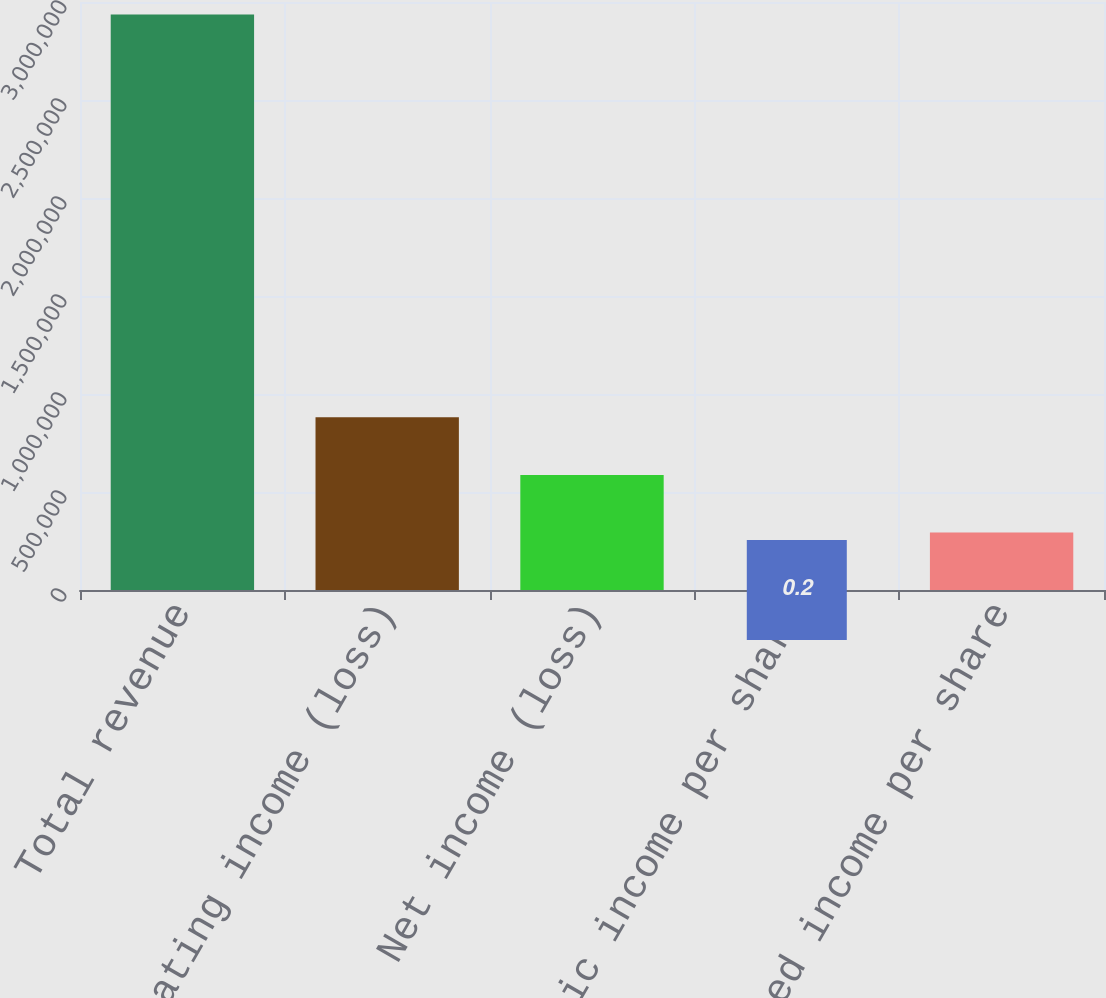Convert chart. <chart><loc_0><loc_0><loc_500><loc_500><bar_chart><fcel>Total revenue<fcel>Operating income (loss)<fcel>Net income (loss)<fcel>Basic income per share<fcel>Diluted income per share<nl><fcel>2.93678e+06<fcel>881034<fcel>587356<fcel>0.2<fcel>293678<nl></chart> 